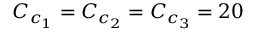<formula> <loc_0><loc_0><loc_500><loc_500>C _ { c _ { 1 } } = C _ { c _ { 2 } } = C _ { c _ { 3 } } = 2 0</formula> 